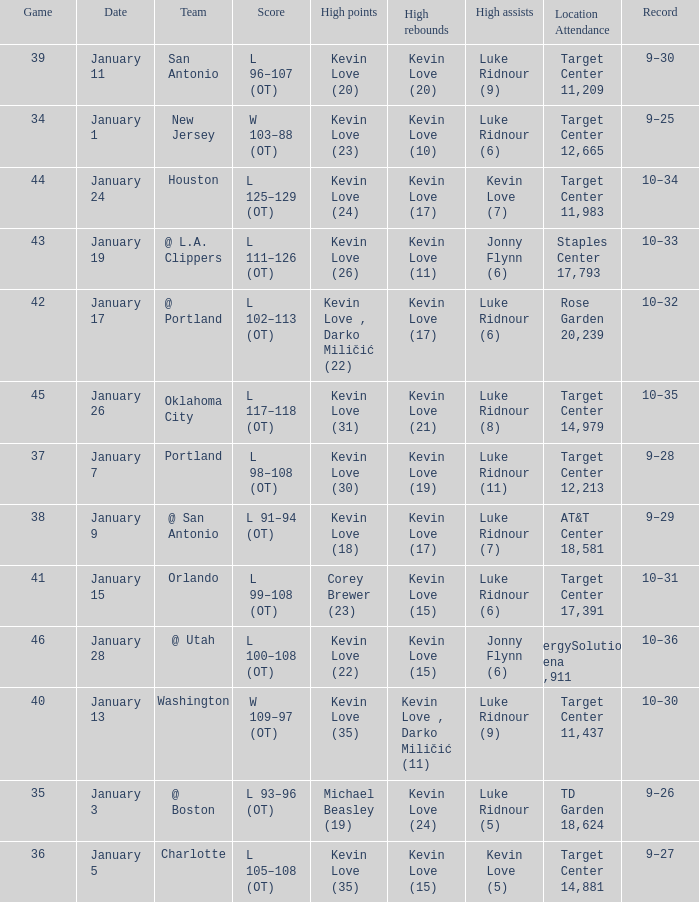What is the highest game with team @ l.a. clippers? 43.0. 